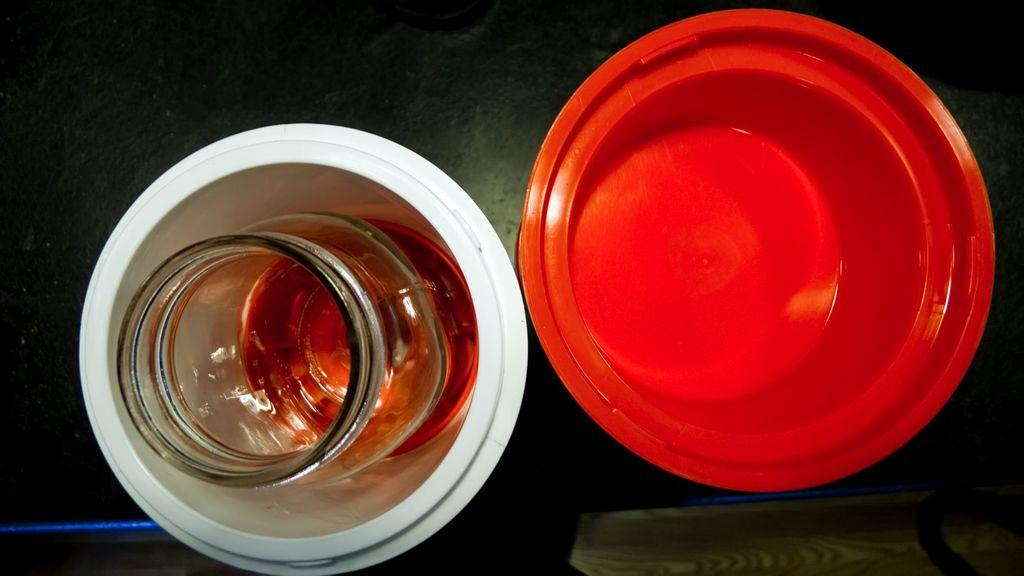What type of containers can be seen in the image? There are bowls in the image. What else is present in the image besides the bowls? There is a jar with liquid in the image. What other objects can be seen on the table in the image? Other objects are present on the table in the image, but their specific details are not mentioned in the provided facts. Is there a person sleeping in the image? There is no person present in the image, let alone sleeping. Are there any mittens visible in the image? There is no mention of mittens in the provided facts, and therefore, we cannot determine if any are present in the image. 